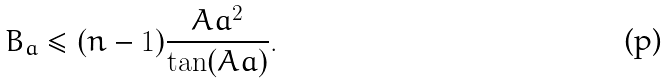<formula> <loc_0><loc_0><loc_500><loc_500>B _ { a } \leq ( n - 1 ) \frac { A a ^ { 2 } } { \tan ( A a ) } .</formula> 